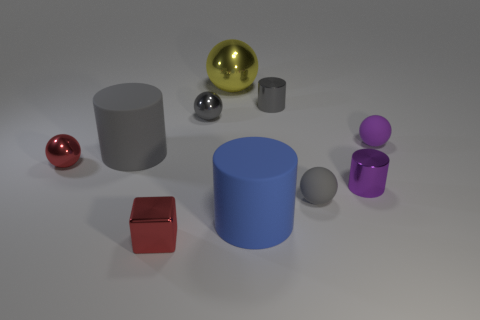Is there a red cube that is in front of the small red metal block right of the red shiny object left of the big gray cylinder?
Provide a succinct answer. No. How big is the gray object that is both in front of the purple ball and left of the yellow ball?
Your response must be concise. Large. How many big blue cylinders are made of the same material as the small purple cylinder?
Offer a very short reply. 0. What number of cubes are yellow shiny things or big brown matte things?
Your answer should be compact. 0. What size is the blue object that is left of the matte ball behind the large cylinder that is on the left side of the big yellow ball?
Your answer should be very brief. Large. There is a tiny shiny thing that is both in front of the large gray rubber cylinder and right of the metallic cube; what is its color?
Ensure brevity in your answer.  Purple. There is a block; is it the same size as the gray matte object behind the tiny purple shiny object?
Your answer should be very brief. No. What is the color of the other tiny matte object that is the same shape as the purple matte object?
Provide a succinct answer. Gray. Is the size of the gray matte cylinder the same as the red ball?
Provide a succinct answer. No. What number of other objects are the same size as the red metallic sphere?
Offer a terse response. 6. 